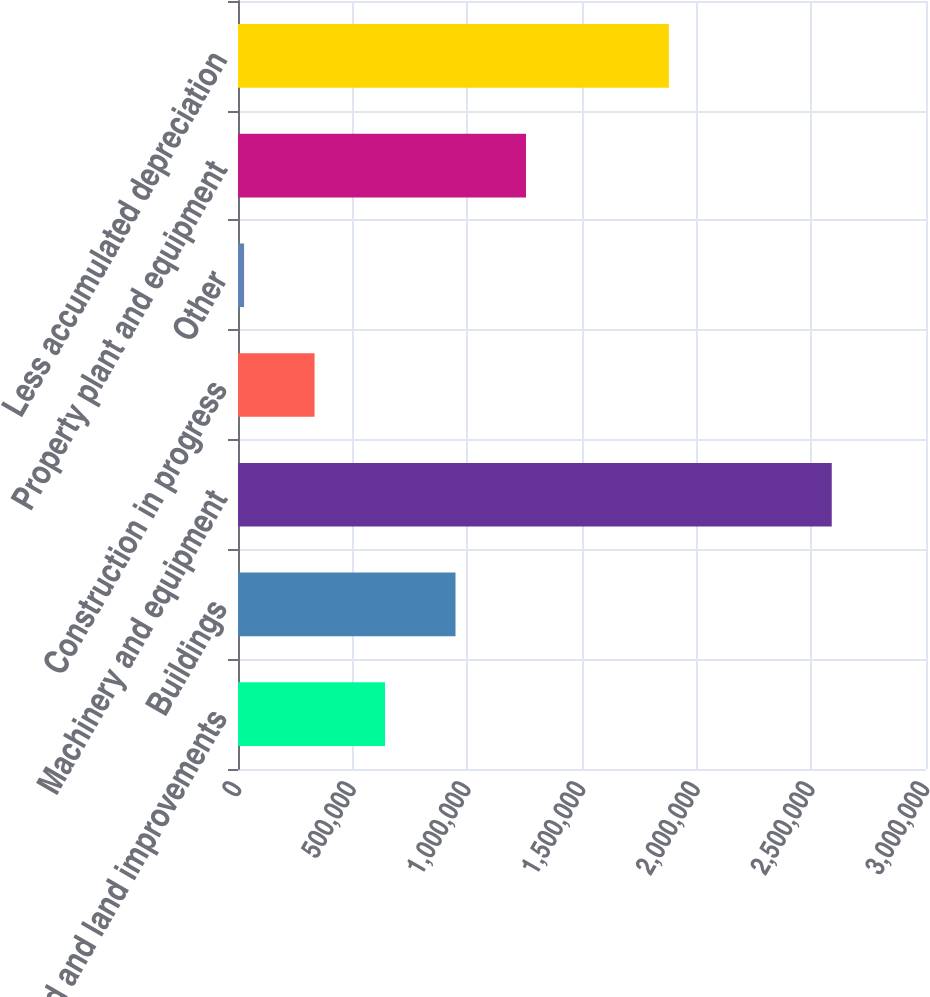<chart> <loc_0><loc_0><loc_500><loc_500><bar_chart><fcel>Land and land improvements<fcel>Buildings<fcel>Machinery and equipment<fcel>Construction in progress<fcel>Other<fcel>Property plant and equipment<fcel>Less accumulated depreciation<nl><fcel>641134<fcel>948471<fcel>2.589e+06<fcel>333796<fcel>26459<fcel>1.25581e+06<fcel>1.87881e+06<nl></chart> 